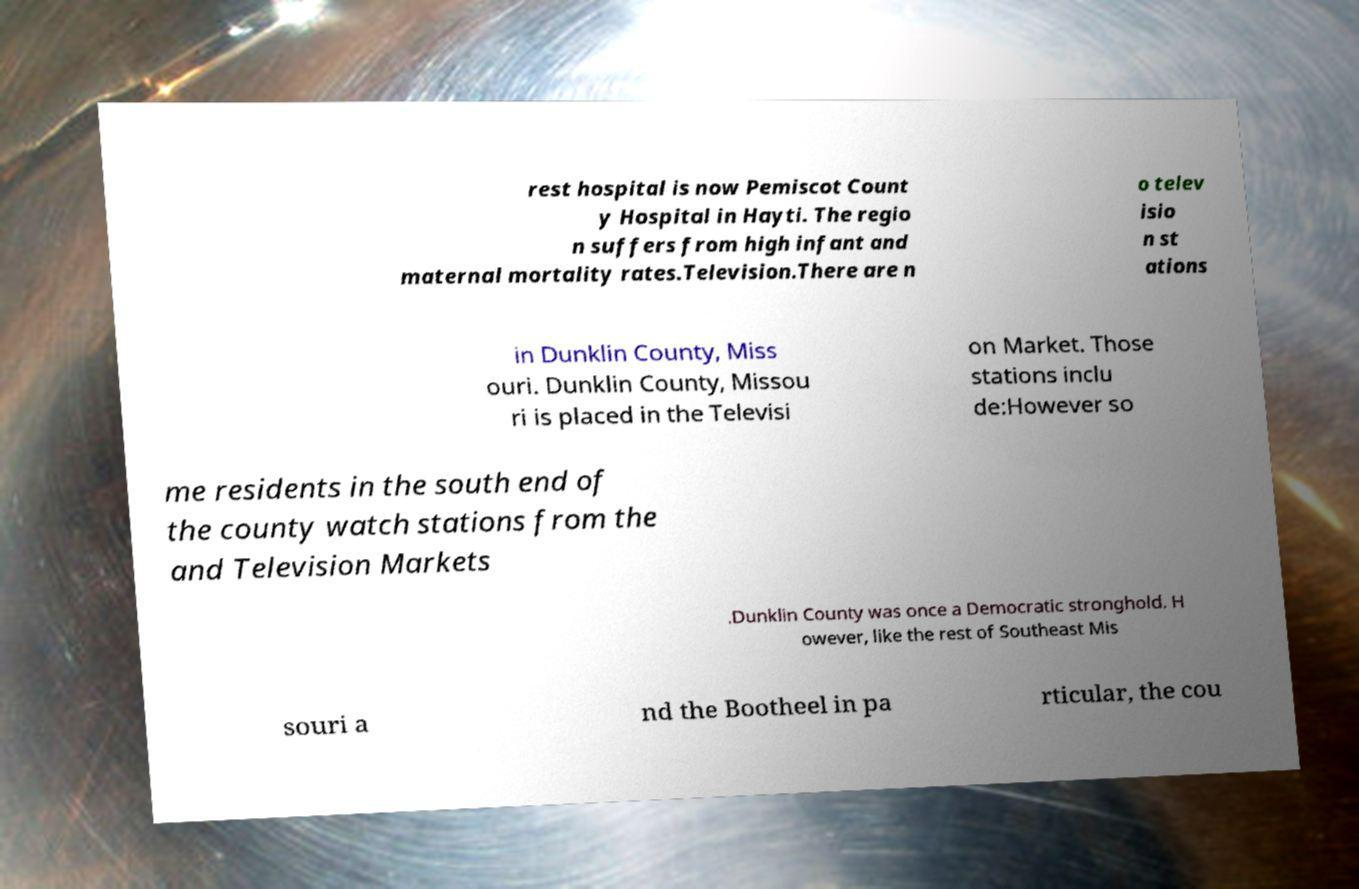What messages or text are displayed in this image? I need them in a readable, typed format. rest hospital is now Pemiscot Count y Hospital in Hayti. The regio n suffers from high infant and maternal mortality rates.Television.There are n o telev isio n st ations in Dunklin County, Miss ouri. Dunklin County, Missou ri is placed in the Televisi on Market. Those stations inclu de:However so me residents in the south end of the county watch stations from the and Television Markets .Dunklin County was once a Democratic stronghold. H owever, like the rest of Southeast Mis souri a nd the Bootheel in pa rticular, the cou 